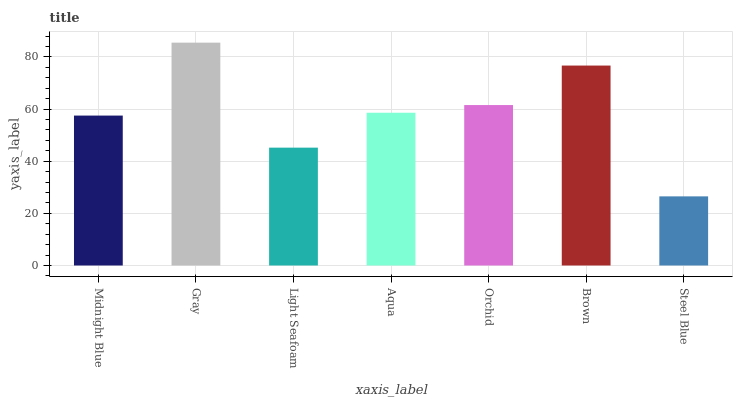Is Steel Blue the minimum?
Answer yes or no. Yes. Is Gray the maximum?
Answer yes or no. Yes. Is Light Seafoam the minimum?
Answer yes or no. No. Is Light Seafoam the maximum?
Answer yes or no. No. Is Gray greater than Light Seafoam?
Answer yes or no. Yes. Is Light Seafoam less than Gray?
Answer yes or no. Yes. Is Light Seafoam greater than Gray?
Answer yes or no. No. Is Gray less than Light Seafoam?
Answer yes or no. No. Is Aqua the high median?
Answer yes or no. Yes. Is Aqua the low median?
Answer yes or no. Yes. Is Orchid the high median?
Answer yes or no. No. Is Midnight Blue the low median?
Answer yes or no. No. 